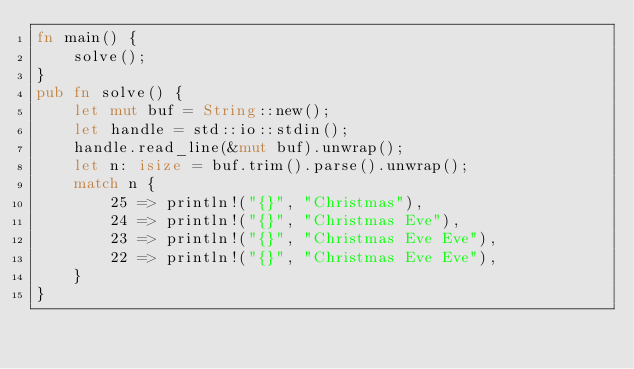Convert code to text. <code><loc_0><loc_0><loc_500><loc_500><_Rust_>fn main() {
    solve();
}
pub fn solve() {
    let mut buf = String::new();
    let handle = std::io::stdin();
    handle.read_line(&mut buf).unwrap();
    let n: isize = buf.trim().parse().unwrap();
    match n {
        25 => println!("{}", "Christmas"),
        24 => println!("{}", "Christmas Eve"),
        23 => println!("{}", "Christmas Eve Eve"),
        22 => println!("{}", "Christmas Eve Eve"),
    }
}</code> 